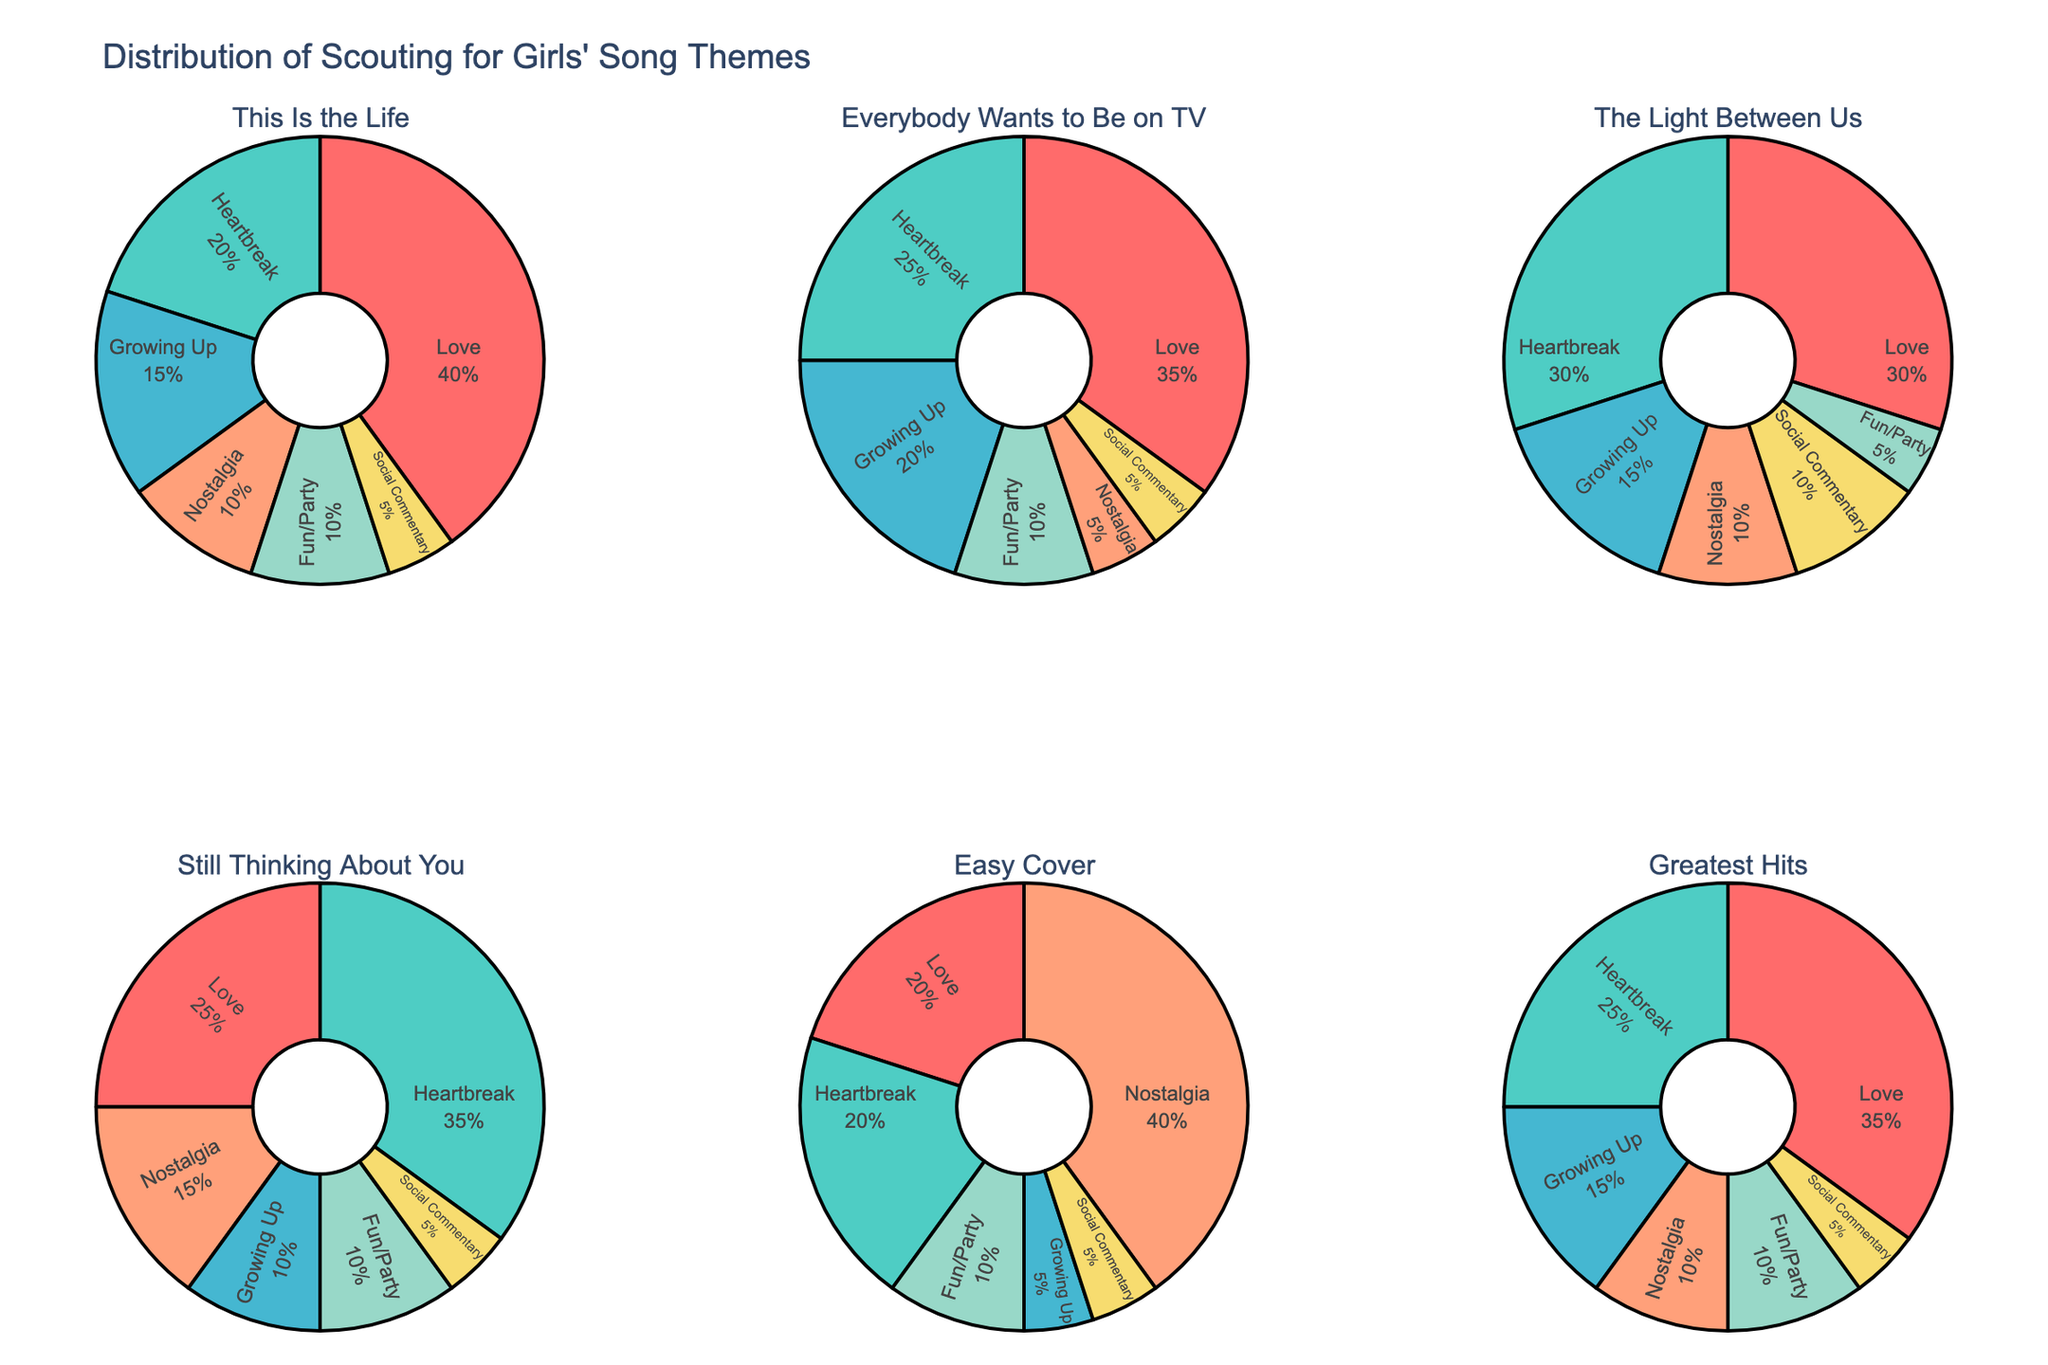How many albums have "Heartbreak" as the highest percentage theme? "Heartbreak" is the highest percentage theme if it covers the largest portion of the pie. Check each pie chart for the album where the "Heartbreak" segment is the largest compared to other themes in the same chart. "Everybody Wants to Be on TV", "The Light Between Us", and "Still Thinking About You" have "Heartbreak" as the largest segment.
Answer: 3 Which album has the largest percentage of "Nostalgia"? Locate each "Nostalgia" segment in the pie charts and compare their percentages. "Easy Cover" has the largest "Nostalgia" segment with 40%.
Answer: Easy Cover What's the total percentage for "Heartbreak" and "Growing Up" in "Everybody Wants to Be on TV"? For "Everybody Wants to Be on TV" album, the percentages are 25% for "Heartbreak" and 20% for "Growing Up". Sum them up: 25% + 20% = 45%.
Answer: 45% Which album's pie chart has the smallest segment for "Fun/Party"? Look for the smallest "Fun/Party" segment in each pie chart. For "The Light Between Us", the "Fun/Party" segment is 5%, which is the smallest compared to other albums.
Answer: The Light Between Us How does the percentage of "Love" compare between "This Is the Life" and "Still Thinking About You"? Compare the "Love" segments in both albums. "This Is the Life" has 40% and "Still Thinking About You" has 25%. "This Is the Life" has a larger percentage of "Love".
Answer: This Is the Life What theme is the most consistent across all albums in terms of percentage? Examine each pie chart to identify a theme with similar percentages across all albums. "Social Commentary" has the most consistent percentages, mostly around 5%.
Answer: Social Commentary If you combine "Growing Up" and "Nostalgia" percentages for "Easy Cover", what's the result? For "Easy Cover", "Growing Up" is 5% and "Nostalgia" is 40%. Sum them up: 5% + 40% = 45%.
Answer: 45% What percentage of "Love" do "The Light Between Us" and "Everybody Wants to Be on TV" contribute together? Add the "Love" percentages of "The Light Between Us" (30%) and "Everybody Wants to Be on TV" (35%): 30% + 35% = 65%.
Answer: 65% Which album has the smallest "Love" percentage? Find the "Love" segment with the smallest percentage across all pie charts. "Easy Cover" has the smallest "Love" segment with 20%.
Answer: Easy Cover 